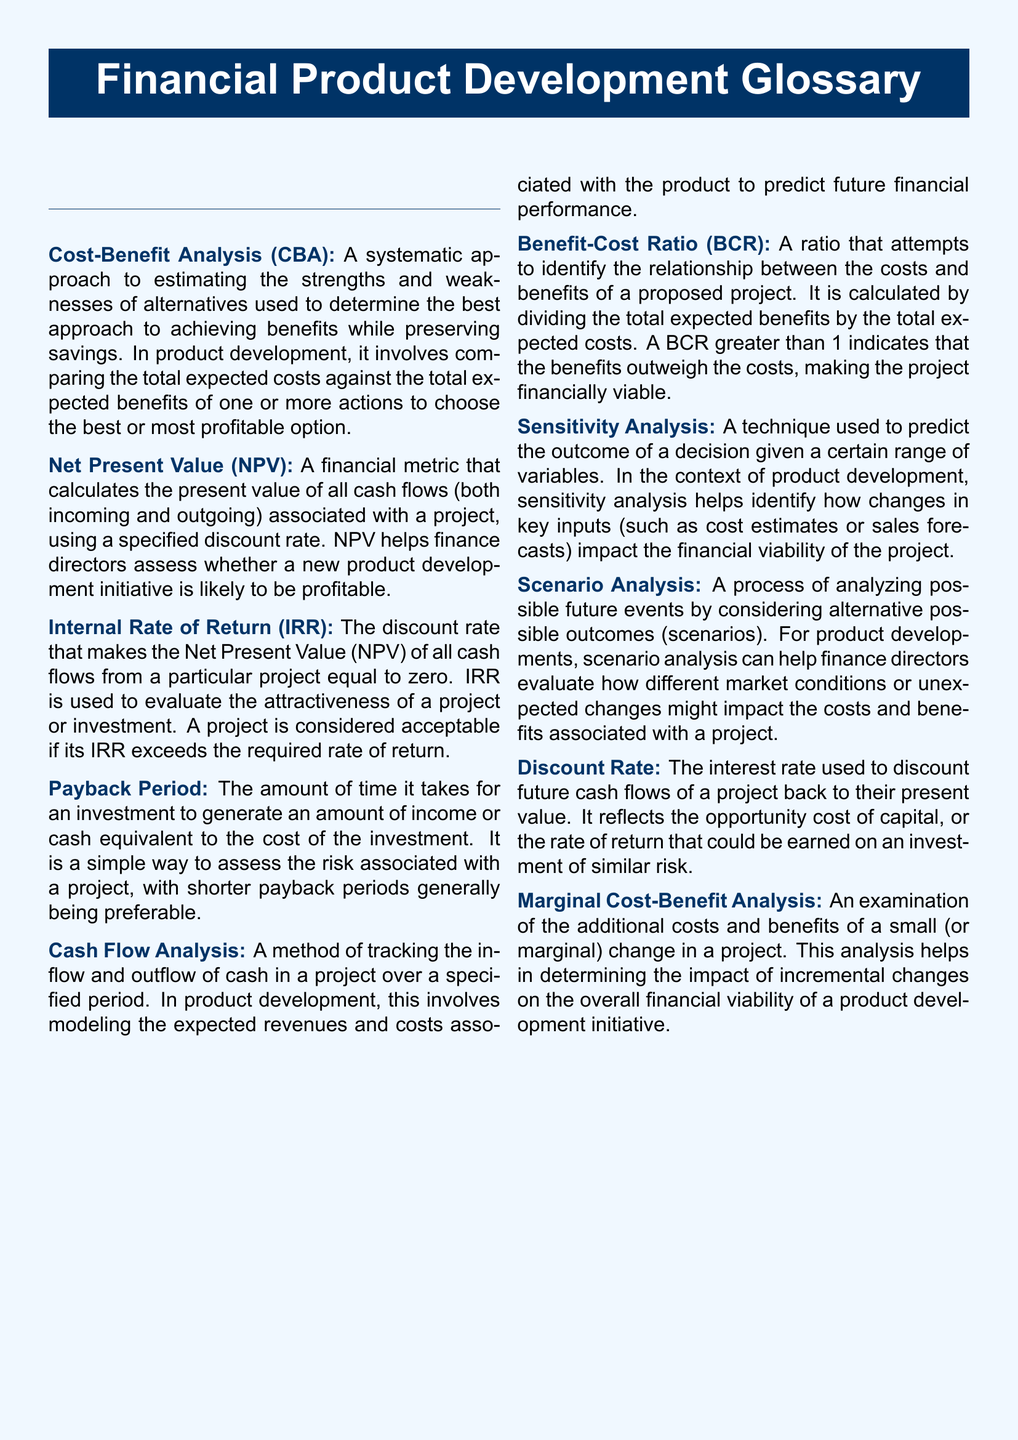What is Cost-Benefit Analysis? Cost-Benefit Analysis is defined as a systematic approach to estimating the strengths and weaknesses of alternatives used to determine the best approach to achieving benefits while preserving savings.
Answer: A systematic approach to estimating the strengths and weaknesses of alternatives used to determine the best approach to achieving benefits while preserving savings What does NPV stand for? NPV stands for Net Present Value, which is a financial metric that calculates the present value of all cash flows associated with a project.
Answer: Net Present Value What is the main purpose of the Internal Rate of Return? The Internal Rate of Return (IRR) is used to evaluate the attractiveness of a project or investment by determining the discount rate that makes the NPV equal to zero.
Answer: To evaluate the attractiveness of a project or investment What does a Benefit-Cost Ratio greater than 1 indicate? A Benefit-Cost Ratio (BCR) greater than 1 indicates that the benefits outweigh the costs, making the project financially viable.
Answer: That the benefits outweigh the costs What analysis helps identify how changes in key inputs impact financial viability? Sensitivity Analysis helps in predicting the outcome of decisions based on changes in key inputs affecting financial viability.
Answer: Sensitivity Analysis What is the primary focus of Marginal Cost-Benefit Analysis? Marginal Cost-Benefit Analysis focuses on examining the additional costs and benefits of a small or marginal change in a project.
Answer: The additional costs and benefits of a small change What is a Discount Rate? A Discount Rate is the interest rate used to discount future cash flows of a project back to their present value.
Answer: The interest rate used to discount future cash flows What does Scenario Analysis evaluate? Scenario Analysis evaluates possible future events by considering alternative possible outcomes or scenarios that might impact costs and benefits.
Answer: Possible future events by considering alternative possible outcomes What is the Payback Period? The Payback Period is defined as the amount of time it takes for an investment to generate an amount of income or cash equivalent to the cost of the investment.
Answer: The amount of time it takes for an investment to generate income equivalent to its cost 